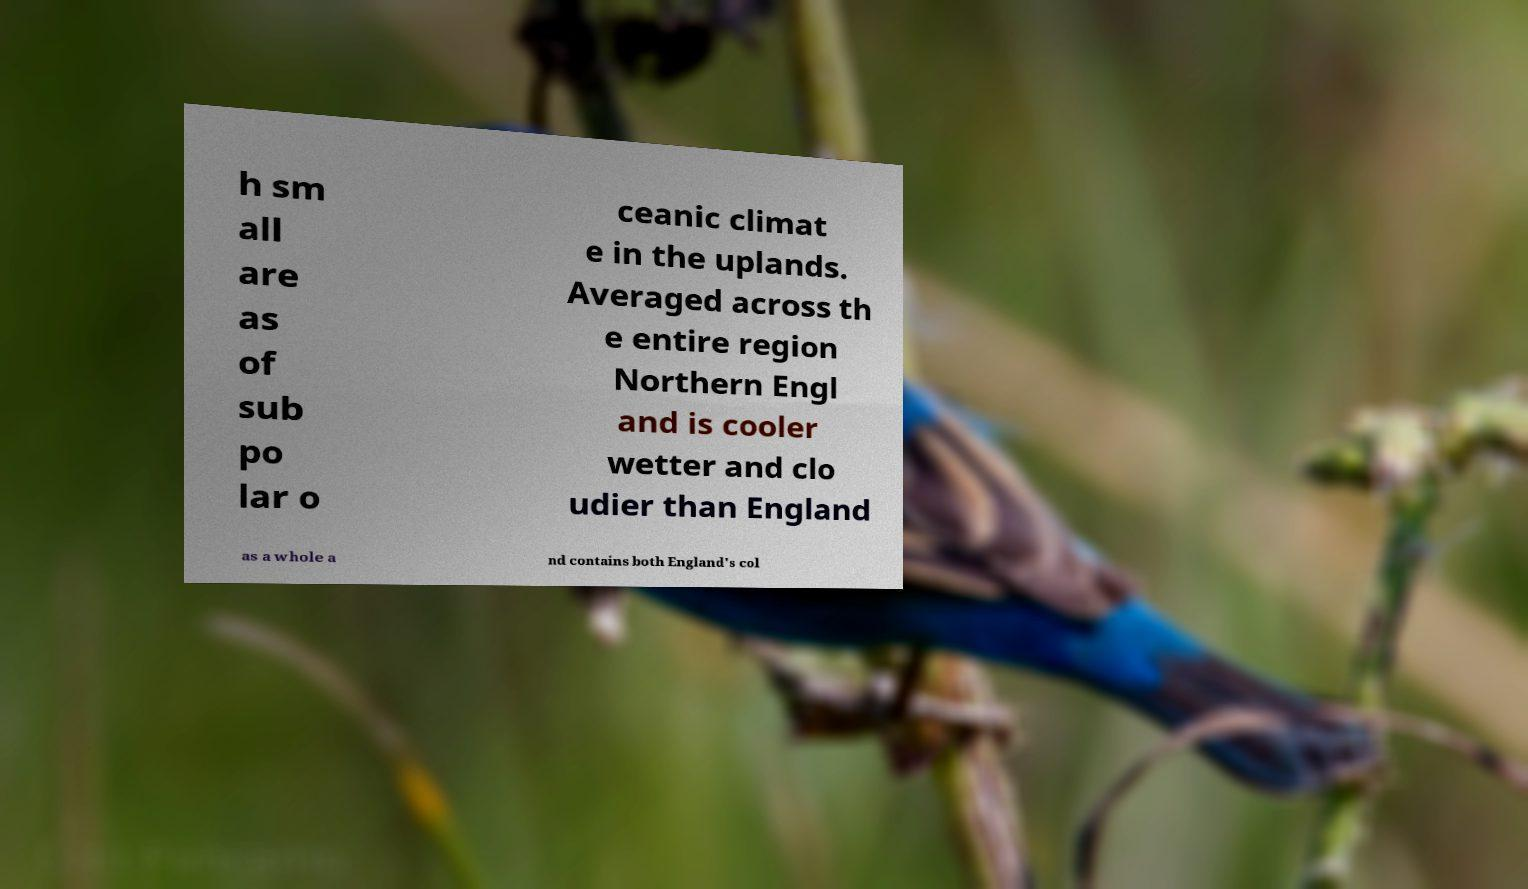There's text embedded in this image that I need extracted. Can you transcribe it verbatim? h sm all are as of sub po lar o ceanic climat e in the uplands. Averaged across th e entire region Northern Engl and is cooler wetter and clo udier than England as a whole a nd contains both England's col 